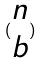<formula> <loc_0><loc_0><loc_500><loc_500>( \begin{matrix} n \\ b \end{matrix} )</formula> 